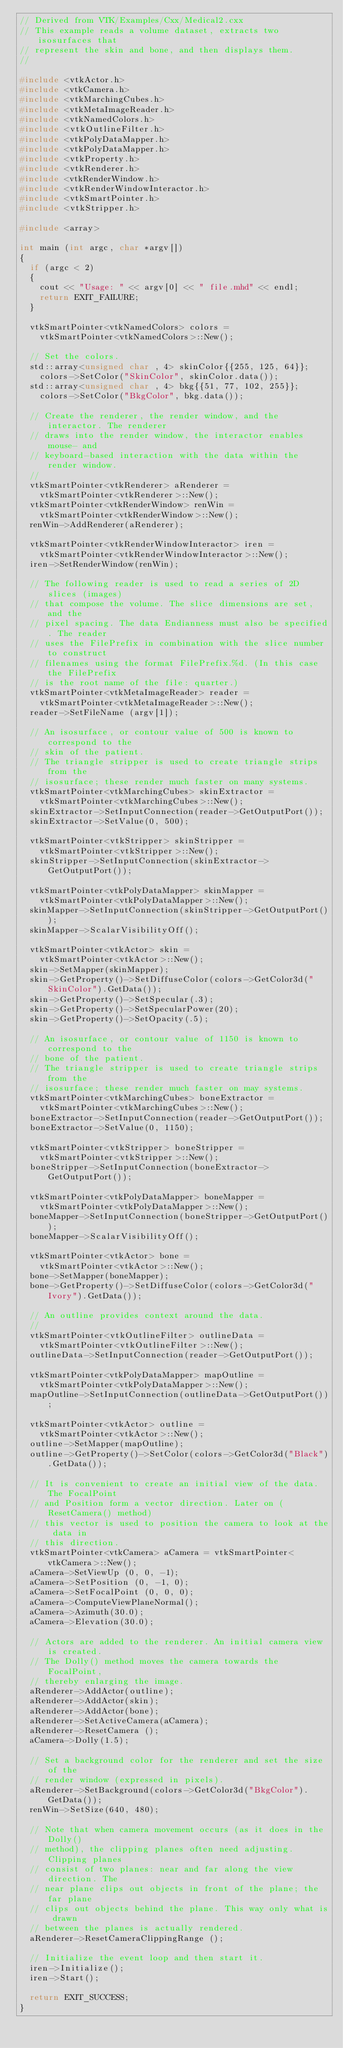Convert code to text. <code><loc_0><loc_0><loc_500><loc_500><_C++_>// Derived from VTK/Examples/Cxx/Medical2.cxx
// This example reads a volume dataset, extracts two isosurfaces that
// represent the skin and bone, and then displays them.
//

#include <vtkActor.h>
#include <vtkCamera.h>
#include <vtkMarchingCubes.h>
#include <vtkMetaImageReader.h>
#include <vtkNamedColors.h>
#include <vtkOutlineFilter.h>
#include <vtkPolyDataMapper.h>
#include <vtkPolyDataMapper.h>
#include <vtkProperty.h>
#include <vtkRenderer.h>
#include <vtkRenderWindow.h>
#include <vtkRenderWindowInteractor.h>
#include <vtkSmartPointer.h>
#include <vtkStripper.h>

#include <array>

int main (int argc, char *argv[])
{
  if (argc < 2)
  {
    cout << "Usage: " << argv[0] << " file.mhd" << endl;
    return EXIT_FAILURE;
  }

  vtkSmartPointer<vtkNamedColors> colors =
    vtkSmartPointer<vtkNamedColors>::New();

  // Set the colors.
  std::array<unsigned char , 4> skinColor{{255, 125, 64}};
    colors->SetColor("SkinColor", skinColor.data());
  std::array<unsigned char , 4> bkg{{51, 77, 102, 255}};
    colors->SetColor("BkgColor", bkg.data());

  // Create the renderer, the render window, and the interactor. The renderer
  // draws into the render window, the interactor enables mouse- and
  // keyboard-based interaction with the data within the render window.
  //
  vtkSmartPointer<vtkRenderer> aRenderer =
    vtkSmartPointer<vtkRenderer>::New();
  vtkSmartPointer<vtkRenderWindow> renWin =
    vtkSmartPointer<vtkRenderWindow>::New();
  renWin->AddRenderer(aRenderer);

  vtkSmartPointer<vtkRenderWindowInteractor> iren =
    vtkSmartPointer<vtkRenderWindowInteractor>::New();
  iren->SetRenderWindow(renWin);

  // The following reader is used to read a series of 2D slices (images)
  // that compose the volume. The slice dimensions are set, and the
  // pixel spacing. The data Endianness must also be specified. The reader
  // uses the FilePrefix in combination with the slice number to construct
  // filenames using the format FilePrefix.%d. (In this case the FilePrefix
  // is the root name of the file: quarter.)
  vtkSmartPointer<vtkMetaImageReader> reader =
    vtkSmartPointer<vtkMetaImageReader>::New();
  reader->SetFileName (argv[1]);

  // An isosurface, or contour value of 500 is known to correspond to the
  // skin of the patient.
  // The triangle stripper is used to create triangle strips from the
  // isosurface; these render much faster on many systems.
  vtkSmartPointer<vtkMarchingCubes> skinExtractor =
    vtkSmartPointer<vtkMarchingCubes>::New();
  skinExtractor->SetInputConnection(reader->GetOutputPort());
  skinExtractor->SetValue(0, 500);

  vtkSmartPointer<vtkStripper> skinStripper =
    vtkSmartPointer<vtkStripper>::New();
  skinStripper->SetInputConnection(skinExtractor->GetOutputPort());

  vtkSmartPointer<vtkPolyDataMapper> skinMapper =
    vtkSmartPointer<vtkPolyDataMapper>::New();
  skinMapper->SetInputConnection(skinStripper->GetOutputPort());
  skinMapper->ScalarVisibilityOff();

  vtkSmartPointer<vtkActor> skin =
    vtkSmartPointer<vtkActor>::New();
  skin->SetMapper(skinMapper);
  skin->GetProperty()->SetDiffuseColor(colors->GetColor3d("SkinColor").GetData());
  skin->GetProperty()->SetSpecular(.3);
  skin->GetProperty()->SetSpecularPower(20);
  skin->GetProperty()->SetOpacity(.5);

  // An isosurface, or contour value of 1150 is known to correspond to the
  // bone of the patient.
  // The triangle stripper is used to create triangle strips from the
  // isosurface; these render much faster on may systems.
  vtkSmartPointer<vtkMarchingCubes> boneExtractor =
    vtkSmartPointer<vtkMarchingCubes>::New();
  boneExtractor->SetInputConnection(reader->GetOutputPort());
  boneExtractor->SetValue(0, 1150);

  vtkSmartPointer<vtkStripper> boneStripper =
    vtkSmartPointer<vtkStripper>::New();
  boneStripper->SetInputConnection(boneExtractor->GetOutputPort());

  vtkSmartPointer<vtkPolyDataMapper> boneMapper =
    vtkSmartPointer<vtkPolyDataMapper>::New();
  boneMapper->SetInputConnection(boneStripper->GetOutputPort());
  boneMapper->ScalarVisibilityOff();

  vtkSmartPointer<vtkActor> bone =
    vtkSmartPointer<vtkActor>::New();
  bone->SetMapper(boneMapper);
  bone->GetProperty()->SetDiffuseColor(colors->GetColor3d("Ivory").GetData());

  // An outline provides context around the data.
  //
  vtkSmartPointer<vtkOutlineFilter> outlineData =
    vtkSmartPointer<vtkOutlineFilter>::New();
  outlineData->SetInputConnection(reader->GetOutputPort());

  vtkSmartPointer<vtkPolyDataMapper> mapOutline =
    vtkSmartPointer<vtkPolyDataMapper>::New();
  mapOutline->SetInputConnection(outlineData->GetOutputPort());

  vtkSmartPointer<vtkActor> outline =
    vtkSmartPointer<vtkActor>::New();
  outline->SetMapper(mapOutline);
  outline->GetProperty()->SetColor(colors->GetColor3d("Black").GetData());

  // It is convenient to create an initial view of the data. The FocalPoint
  // and Position form a vector direction. Later on (ResetCamera() method)
  // this vector is used to position the camera to look at the data in
  // this direction.
  vtkSmartPointer<vtkCamera> aCamera = vtkSmartPointer<vtkCamera>::New();
  aCamera->SetViewUp (0, 0, -1);
  aCamera->SetPosition (0, -1, 0);
  aCamera->SetFocalPoint (0, 0, 0);
  aCamera->ComputeViewPlaneNormal();
  aCamera->Azimuth(30.0);
  aCamera->Elevation(30.0);

  // Actors are added to the renderer. An initial camera view is created.
  // The Dolly() method moves the camera towards the FocalPoint,
  // thereby enlarging the image.
  aRenderer->AddActor(outline);
  aRenderer->AddActor(skin);
  aRenderer->AddActor(bone);
  aRenderer->SetActiveCamera(aCamera);
  aRenderer->ResetCamera ();
  aCamera->Dolly(1.5);

  // Set a background color for the renderer and set the size of the
  // render window (expressed in pixels).
  aRenderer->SetBackground(colors->GetColor3d("BkgColor").GetData());
  renWin->SetSize(640, 480);

  // Note that when camera movement occurs (as it does in the Dolly()
  // method), the clipping planes often need adjusting. Clipping planes
  // consist of two planes: near and far along the view direction. The
  // near plane clips out objects in front of the plane; the far plane
  // clips out objects behind the plane. This way only what is drawn
  // between the planes is actually rendered.
  aRenderer->ResetCameraClippingRange ();

  // Initialize the event loop and then start it.
  iren->Initialize();
  iren->Start();

  return EXIT_SUCCESS;
}
</code> 